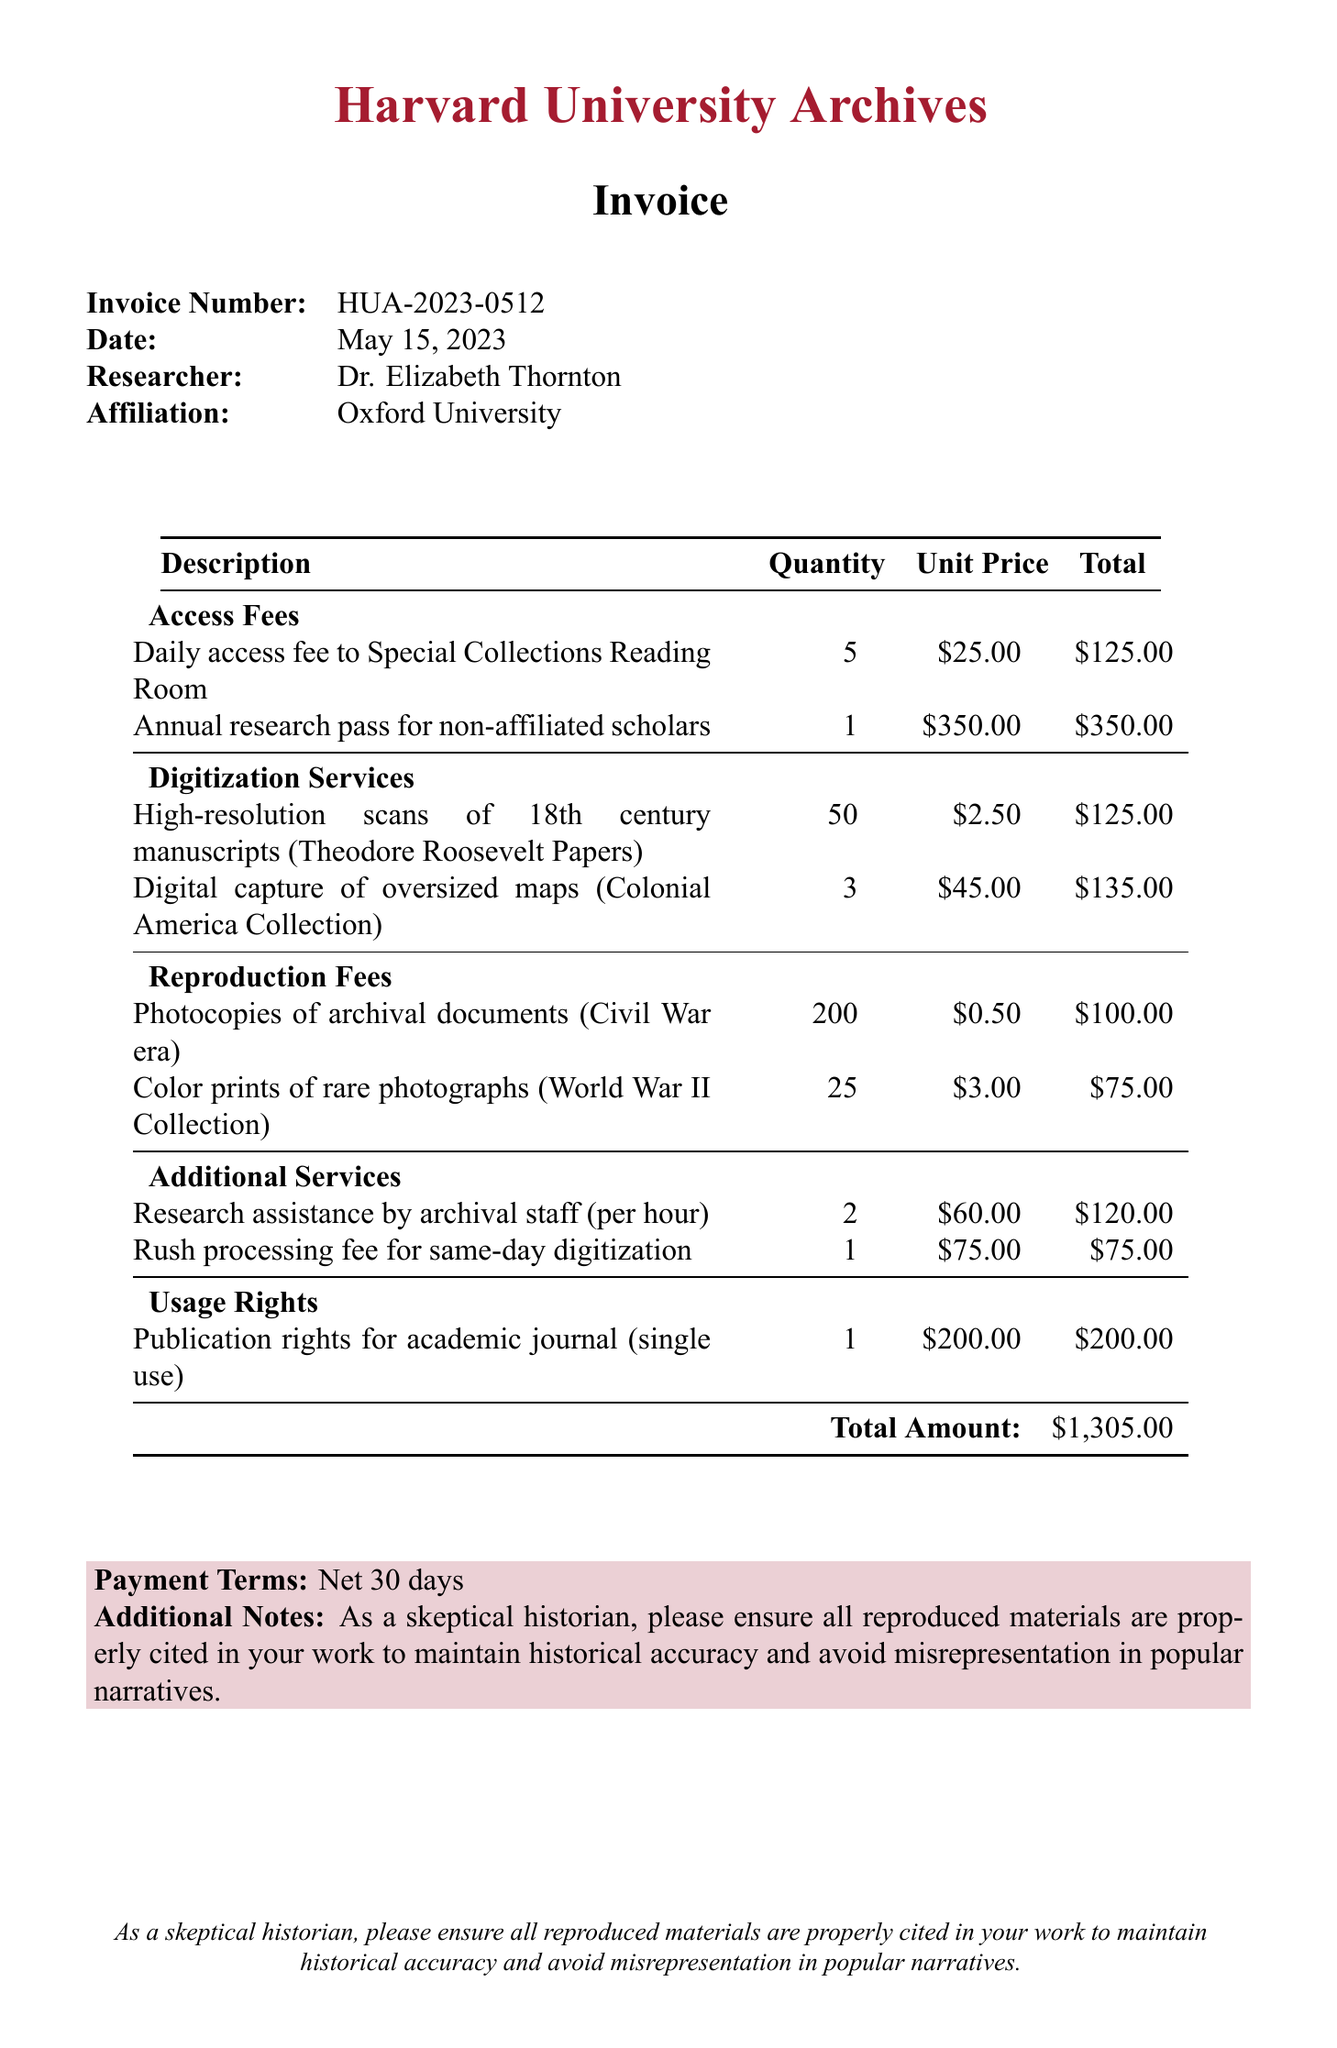What is the institution issuing the invoice? The institution issuing the invoice is stated at the top of the document, identifying the source of the charges.
Answer: Harvard University Archives Who is the researcher associated with the invoice? The researcher’s name is listed in the document, providing the individual responsible for the research services.
Answer: Dr. Elizabeth Thornton What is the total amount due on the invoice? The total amount is specified at the bottom of the document, summarizing all charges incurred.
Answer: $1,305.00 How many high-resolution scans of 18th century manuscripts were requested? The specific quantity of requested scans is detailed within the digitization services section of the document.
Answer: 50 What is the unit price of the annual research pass for non-affiliated scholars? The price for the annual research pass is listed in the access fees section of the invoice.
Answer: $350.00 What type of usage rights are included in this invoice? The usage rights are clearly outlined in the document, specifying the rights associated with reproduction of materials.
Answer: Publication rights for academic journal (single use) What is the payment term specified in the invoice? The payment terms are provided in a dedicated note at the bottom of the document, indicating when payment is expected.
Answer: Net 30 days How much was charged for color prints of rare photographs? The total charge for this reproduction service is added in the reproduction fees section of the document.
Answer: $75.00 What additional service allows for same-day digitization? The additional services section includes a fee for expedited processing, which is clearly named in the document.
Answer: Rush processing fee for same-day digitization 